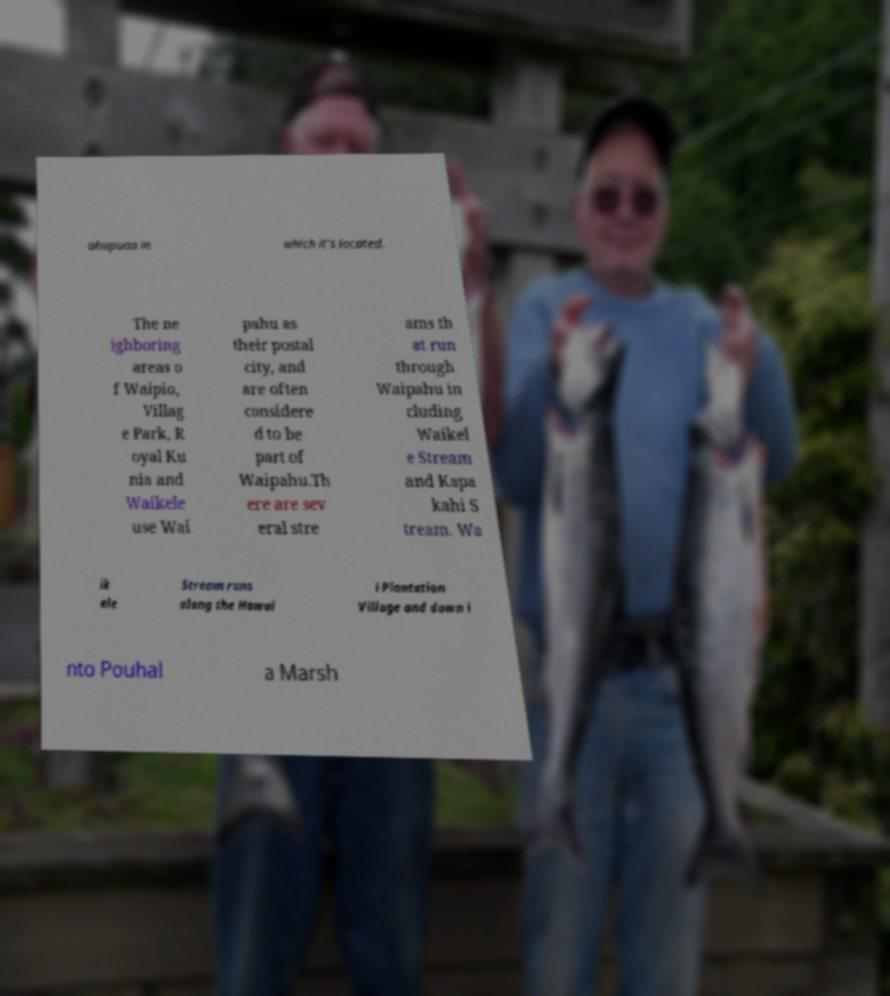Could you extract and type out the text from this image? ahupuaa in which it's located. The ne ighboring areas o f Waipio, Villag e Park, R oyal Ku nia and Waikele use Wai pahu as their postal city, and are often considere d to be part of Waipahu.Th ere are sev eral stre ams th at run through Waipahu in cluding Waikel e Stream and Kapa kahi S tream. Wa ik ele Stream runs along the Hawai i Plantation Village and down i nto Pouhal a Marsh 